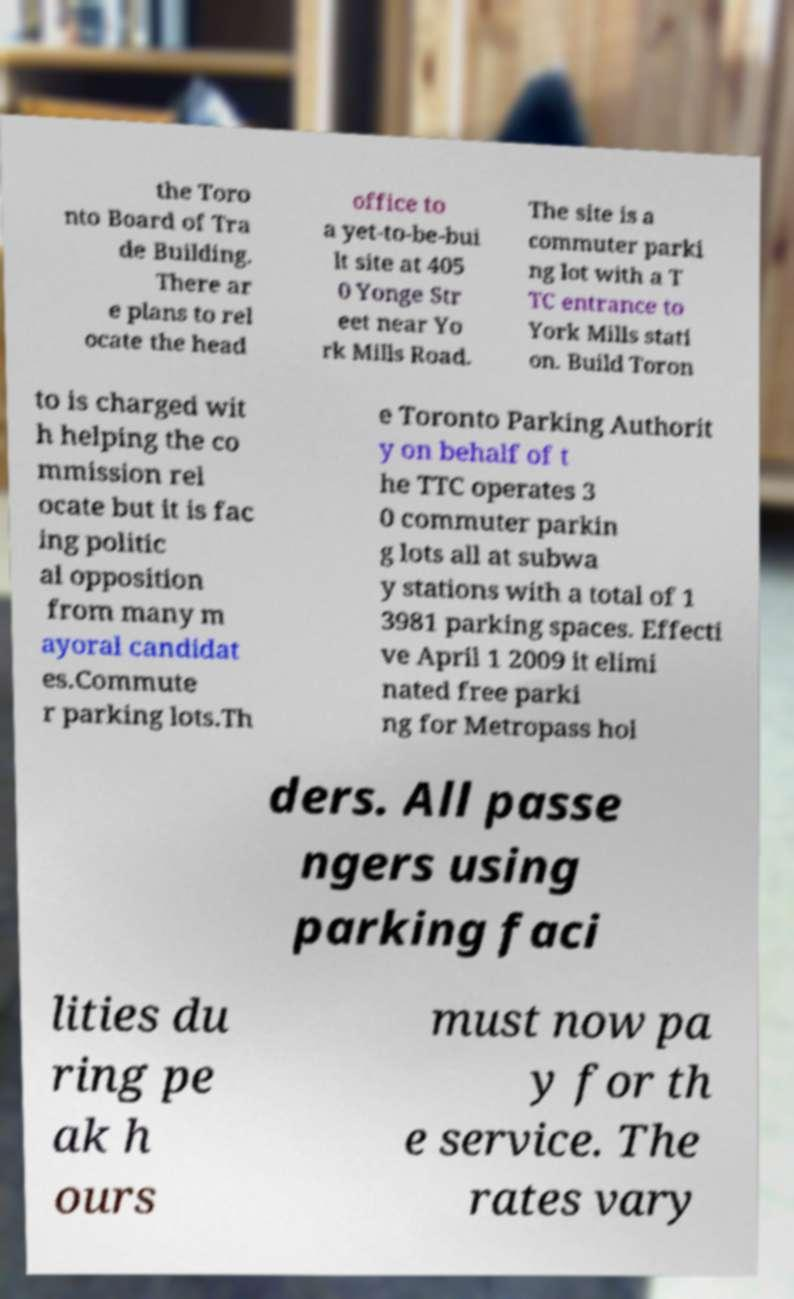I need the written content from this picture converted into text. Can you do that? the Toro nto Board of Tra de Building. There ar e plans to rel ocate the head office to a yet-to-be-bui lt site at 405 0 Yonge Str eet near Yo rk Mills Road. The site is a commuter parki ng lot with a T TC entrance to York Mills stati on. Build Toron to is charged wit h helping the co mmission rel ocate but it is fac ing politic al opposition from many m ayoral candidat es.Commute r parking lots.Th e Toronto Parking Authorit y on behalf of t he TTC operates 3 0 commuter parkin g lots all at subwa y stations with a total of 1 3981 parking spaces. Effecti ve April 1 2009 it elimi nated free parki ng for Metropass hol ders. All passe ngers using parking faci lities du ring pe ak h ours must now pa y for th e service. The rates vary 